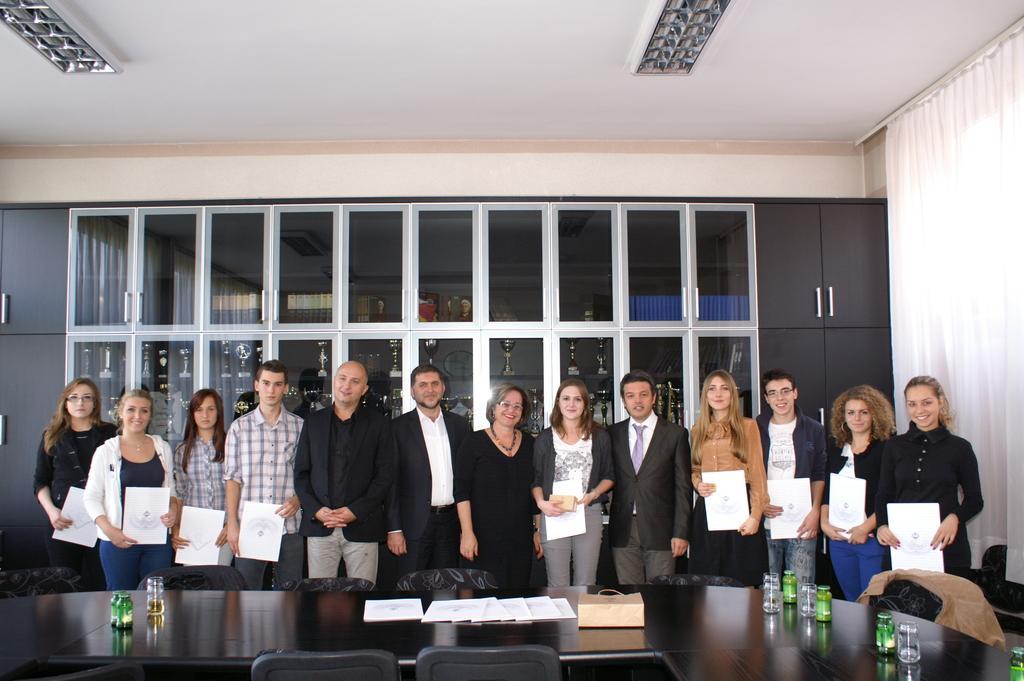Describe this image in one or two sentences. In this picture I can see group of people are standing among them some are holding some objects in their hands. In the background I can see framed glass wall. On the right side I can see curtains and cupboards. In the front I can see a table on which I can see some objects. 